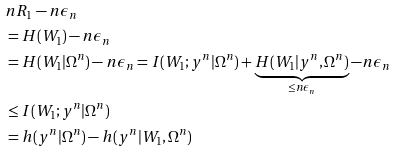Convert formula to latex. <formula><loc_0><loc_0><loc_500><loc_500>& n R _ { 1 } - n \epsilon _ { n } \\ & = H ( W _ { 1 } ) - n \epsilon _ { n } \\ & = H ( W _ { 1 } | \Omega ^ { n } ) - n \epsilon _ { n } = I ( W _ { 1 } ; y ^ { n } | \Omega ^ { n } ) + \underbrace { H ( W _ { 1 } | y ^ { n } , \Omega ^ { n } ) } _ { \leq n \epsilon _ { n } } - n \epsilon _ { n } \\ & \leq I ( W _ { 1 } ; y ^ { n } | \Omega ^ { n } ) \\ & = h ( y ^ { n } | \Omega ^ { n } ) - h ( y ^ { n } | W _ { 1 } , \Omega ^ { n } )</formula> 